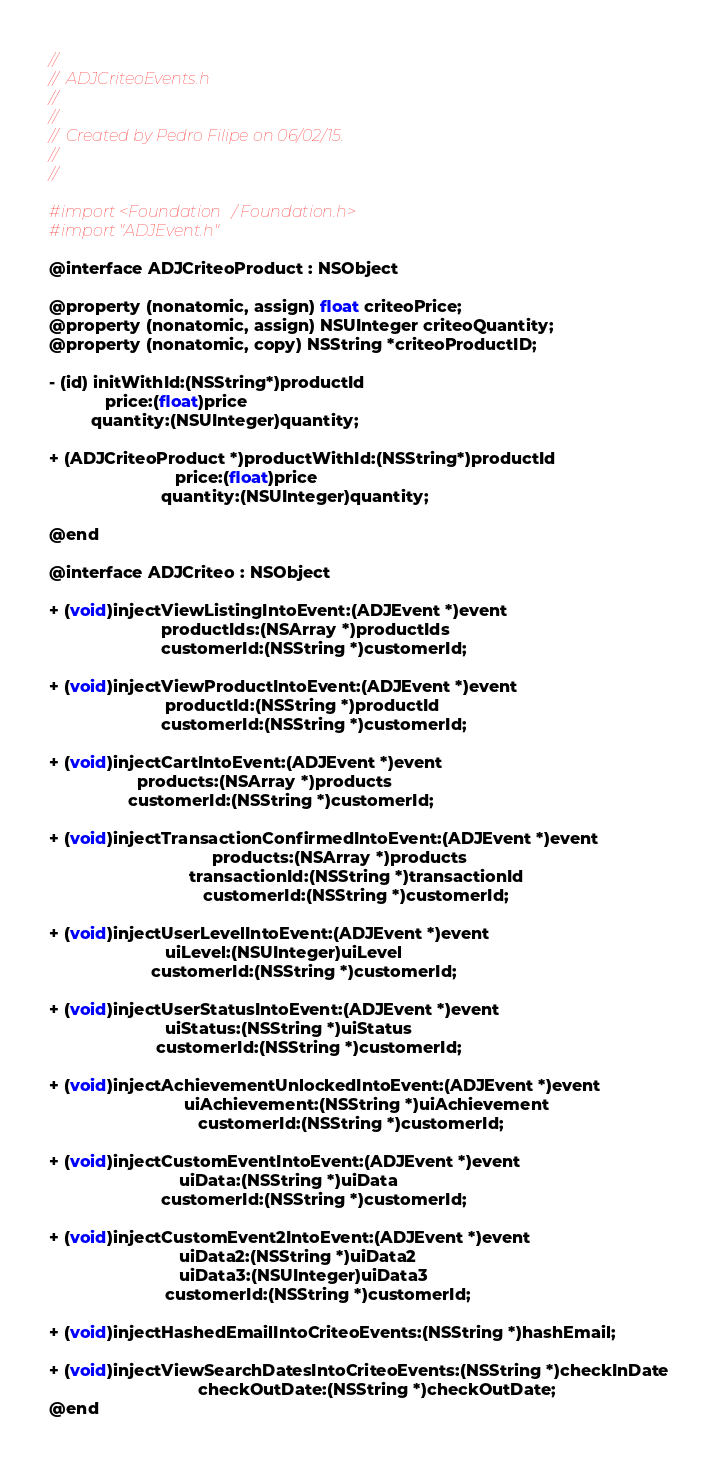Convert code to text. <code><loc_0><loc_0><loc_500><loc_500><_C_>//
//  ADJCriteoEvents.h
//
//
//  Created by Pedro Filipe on 06/02/15.
//
//

#import <Foundation/Foundation.h>
#import "ADJEvent.h"

@interface ADJCriteoProduct : NSObject

@property (nonatomic, assign) float criteoPrice;
@property (nonatomic, assign) NSUInteger criteoQuantity;
@property (nonatomic, copy) NSString *criteoProductID;

- (id) initWithId:(NSString*)productId
            price:(float)price
         quantity:(NSUInteger)quantity;

+ (ADJCriteoProduct *)productWithId:(NSString*)productId
                           price:(float)price
                        quantity:(NSUInteger)quantity;

@end

@interface ADJCriteo : NSObject

+ (void)injectViewListingIntoEvent:(ADJEvent *)event
                        productIds:(NSArray *)productIds
                        customerId:(NSString *)customerId;

+ (void)injectViewProductIntoEvent:(ADJEvent *)event
                         productId:(NSString *)productId
                        customerId:(NSString *)customerId;

+ (void)injectCartIntoEvent:(ADJEvent *)event
                   products:(NSArray *)products
                 customerId:(NSString *)customerId;

+ (void)injectTransactionConfirmedIntoEvent:(ADJEvent *)event
                                   products:(NSArray *)products
                              transactionId:(NSString *)transactionId
                                 customerId:(NSString *)customerId;

+ (void)injectUserLevelIntoEvent:(ADJEvent *)event
                         uiLevel:(NSUInteger)uiLevel
                      customerId:(NSString *)customerId;

+ (void)injectUserStatusIntoEvent:(ADJEvent *)event
                         uiStatus:(NSString *)uiStatus
                       customerId:(NSString *)customerId;

+ (void)injectAchievementUnlockedIntoEvent:(ADJEvent *)event
                             uiAchievement:(NSString *)uiAchievement
                                customerId:(NSString *)customerId;

+ (void)injectCustomEventIntoEvent:(ADJEvent *)event
                            uiData:(NSString *)uiData
                        customerId:(NSString *)customerId;

+ (void)injectCustomEvent2IntoEvent:(ADJEvent *)event
                            uiData2:(NSString *)uiData2
                            uiData3:(NSUInteger)uiData3
                         customerId:(NSString *)customerId;

+ (void)injectHashedEmailIntoCriteoEvents:(NSString *)hashEmail;

+ (void)injectViewSearchDatesIntoCriteoEvents:(NSString *)checkInDate
                                checkOutDate:(NSString *)checkOutDate;
@end
</code> 